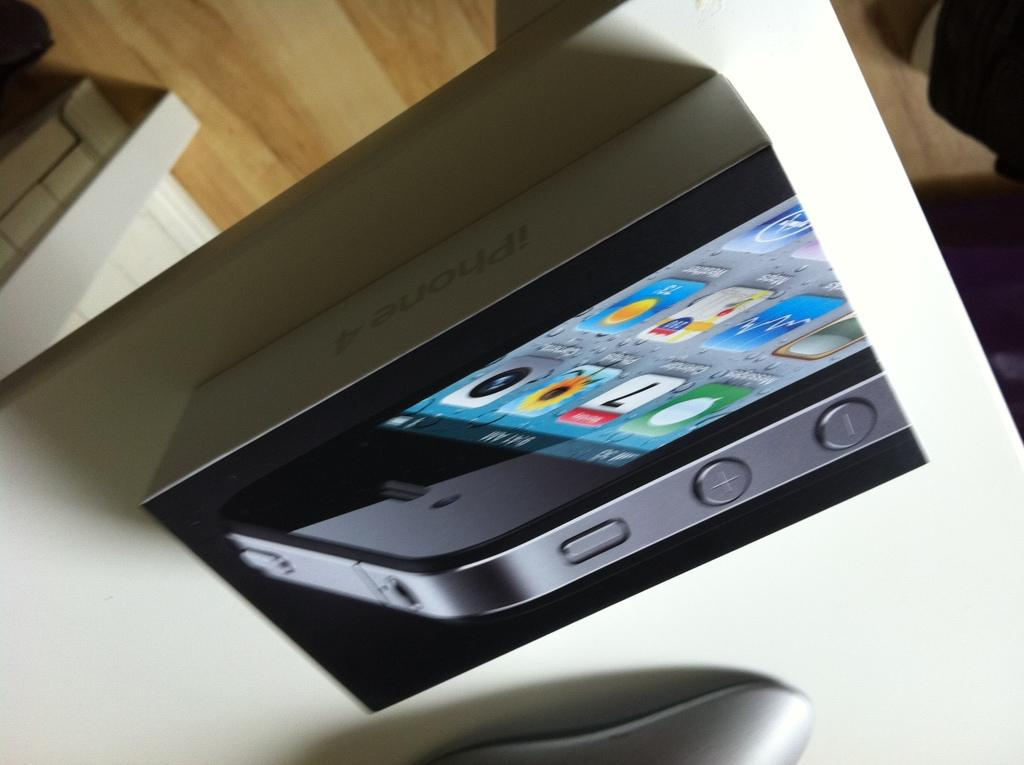What piece of furniture can be seen in the image? There is a table in the image. What is placed on the table? There is a box on the table. What electronic device is on the box? An iPhone is present on the box. What part of the room is visible at the bottom of the image? The floor is visible at the bottom of the image. How many gold coins are scattered on the floor in the image? There are no gold coins present in the image. Can you see any airplanes flying in the background of the image? There is no airplane visible in the image. 